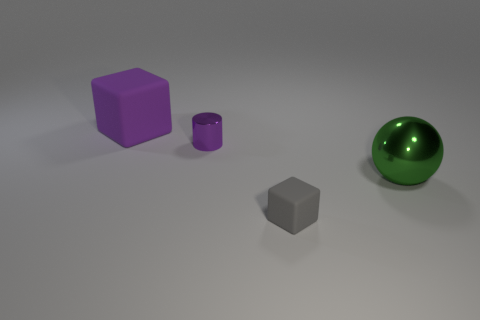Is there any other thing that is the same shape as the large shiny thing?
Offer a terse response. No. How big is the metallic thing on the left side of the green object?
Keep it short and to the point. Small. There is a cube on the right side of the rubber cube behind the tiny metallic thing; how many large blocks are behind it?
Your response must be concise. 1. There is a big matte cube; are there any green shiny objects on the right side of it?
Offer a very short reply. Yes. How many other things are there of the same size as the shiny sphere?
Ensure brevity in your answer.  1. What is the material of the thing that is behind the gray object and to the right of the tiny cylinder?
Offer a very short reply. Metal. Do the large thing on the left side of the tiny gray rubber thing and the tiny object that is in front of the shiny cylinder have the same shape?
Provide a short and direct response. Yes. What is the shape of the metallic object that is to the right of the metallic thing that is behind the object that is to the right of the tiny rubber thing?
Offer a very short reply. Sphere. What number of other objects are the same shape as the purple metallic thing?
Provide a succinct answer. 0. There is a rubber thing that is the same size as the shiny cylinder; what is its color?
Offer a terse response. Gray. 